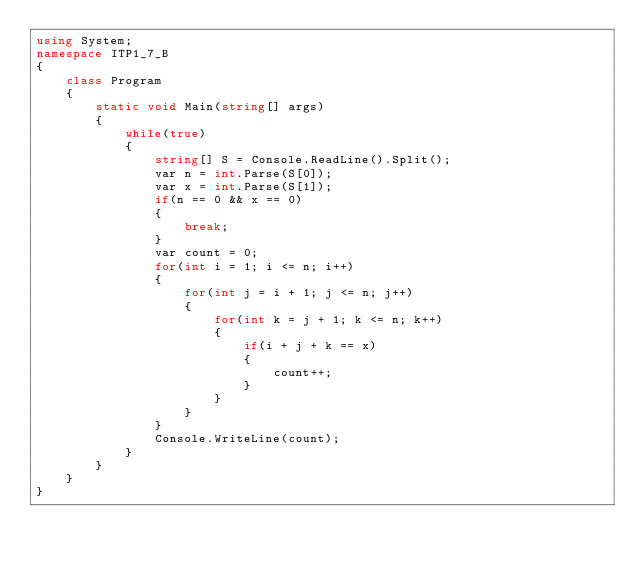Convert code to text. <code><loc_0><loc_0><loc_500><loc_500><_C#_>using System;
namespace ITP1_7_B
{
    class Program
    {
        static void Main(string[] args)
        {
            while(true)
            {
                string[] S = Console.ReadLine().Split();
                var n = int.Parse(S[0]);
                var x = int.Parse(S[1]);
                if(n == 0 && x == 0)
                {
                    break;
                }
                var count = 0;
                for(int i = 1; i <= n; i++)
                {
                    for(int j = i + 1; j <= n; j++)
                    {
                        for(int k = j + 1; k <= n; k++)
                        {
                            if(i + j + k == x)
                            {
                                count++;
                            }
                        }
                    }
                }
                Console.WriteLine(count);
            }
        }
    }
}
</code> 